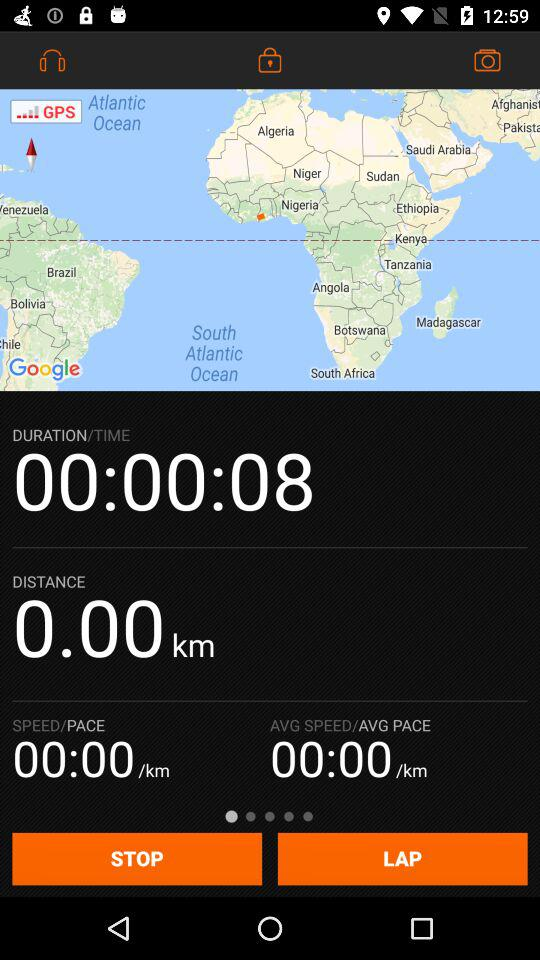What is the duration of the workout?
Answer the question using a single word or phrase. 00:00:08 